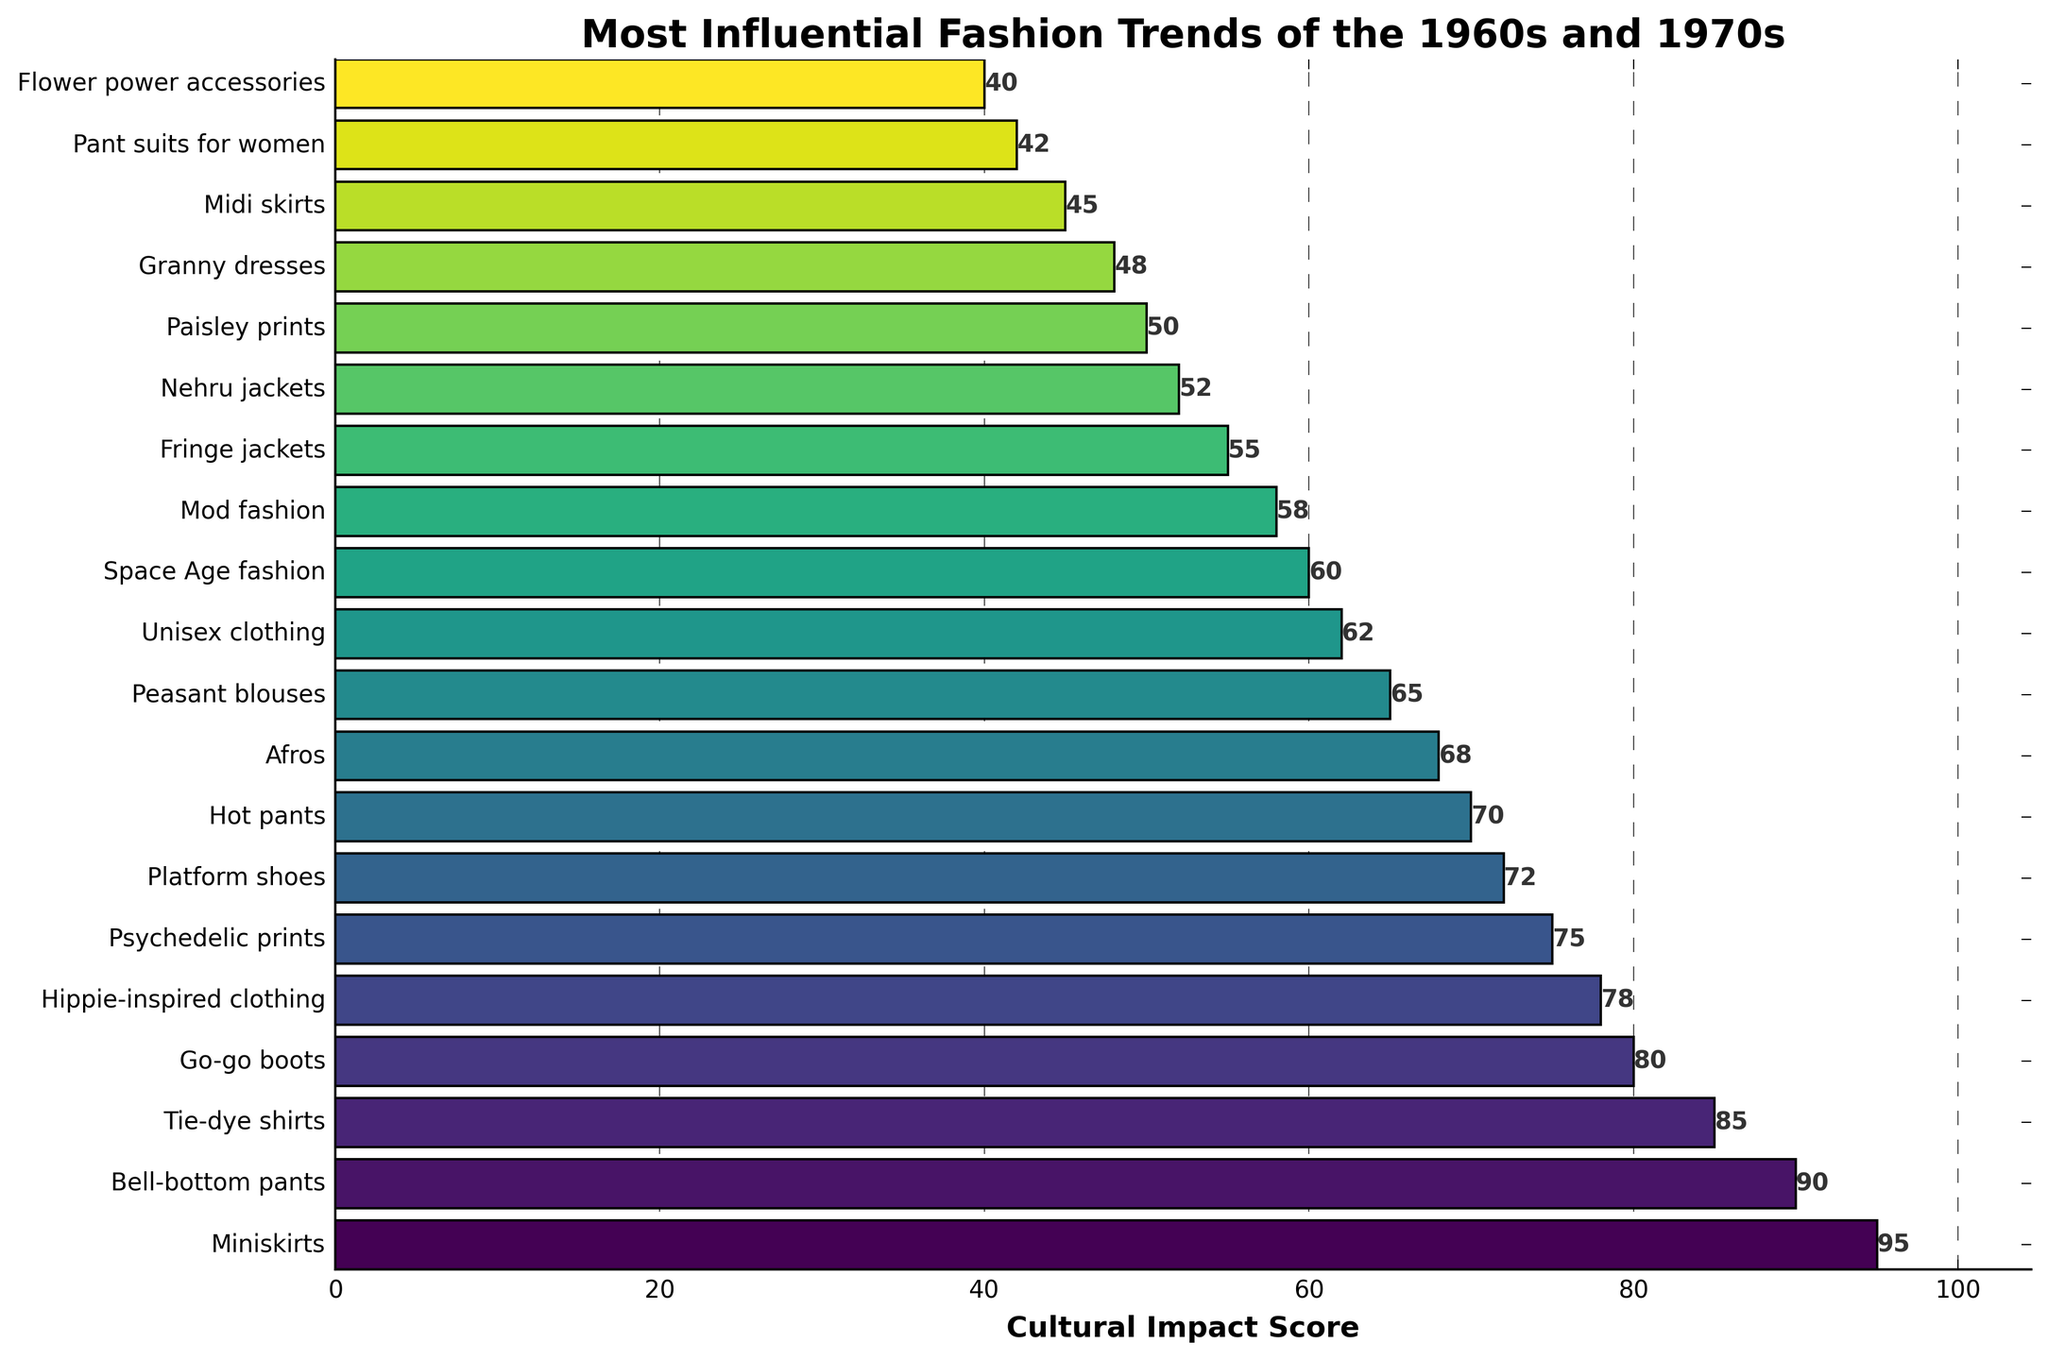Which fashion trend ranks at the top for cultural impact? The bar with the highest cultural impact score corresponds to Miniskirts. This is indicated by the longest bar.
Answer: Miniskirts Which trend has a higher cultural impact score: Psychedelic prints or Peasant blouses? By comparing the lengths of the bars, Psychedelic prints have a cultural impact score of 75, whereas Peasant blouses have a score of 65.
Answer: Psychedelic prints How many fashion trends have a cultural impact score greater than 70? Count the number of bars with values greater than 70. There are 7 such trends: Miniskirts, Bell-bottom pants, Tie-dye shirts, Go-go boots, Hippie-inspired clothing, Psychedelic prints, and Platform shoes.
Answer: 7 What is the difference in cultural impact score between Platform shoes and Afros? Platform shoes have a score of 72 and Afros have a score of 68. Subtract the smaller score from the larger: 72 - 68 = 4.
Answer: 4 Which fashion trend has the lowest cultural impact score? The smallest bar corresponds to Flower power accessories, with a score of 40.
Answer: Flower power accessories What is the total cultural impact score for the top three fashion trends? Sum the cultural impact scores for Miniskirts (95), Bell-bottom pants (90), and Tie-dye shirts (85): 95 + 90 + 85 = 270.
Answer: 270 Which trend is exactly in the middle of the list in terms of cultural impact? Sort the trends by their scores and find the median. For 20 trends, the middle trend is the 10th one when sorted from highest to lowest score. The trend in this position is Afros.
Answer: Afros How does the cultural impact score of Unisex clothing compare to that of Nehru jackets? Unisex clothing has a score of 62 and Nehru jackets have a score of 52. 62 is greater than 52.
Answer: Unisex clothing has a higher score Which trend, among Granny dresses and Midi skirts, has a higher cultural impact score and by how much? Granny dresses have a score of 48 and Midi skirts have a score of 45. The difference is 48 - 45 = 3.
Answer: Granny dresses by 3 